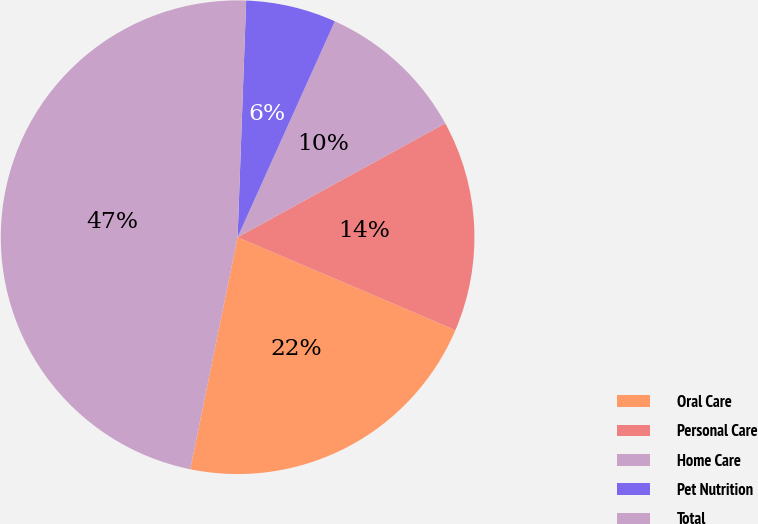Convert chart to OTSL. <chart><loc_0><loc_0><loc_500><loc_500><pie_chart><fcel>Oral Care<fcel>Personal Care<fcel>Home Care<fcel>Pet Nutrition<fcel>Total<nl><fcel>21.79%<fcel>14.4%<fcel>10.28%<fcel>6.16%<fcel>47.37%<nl></chart> 